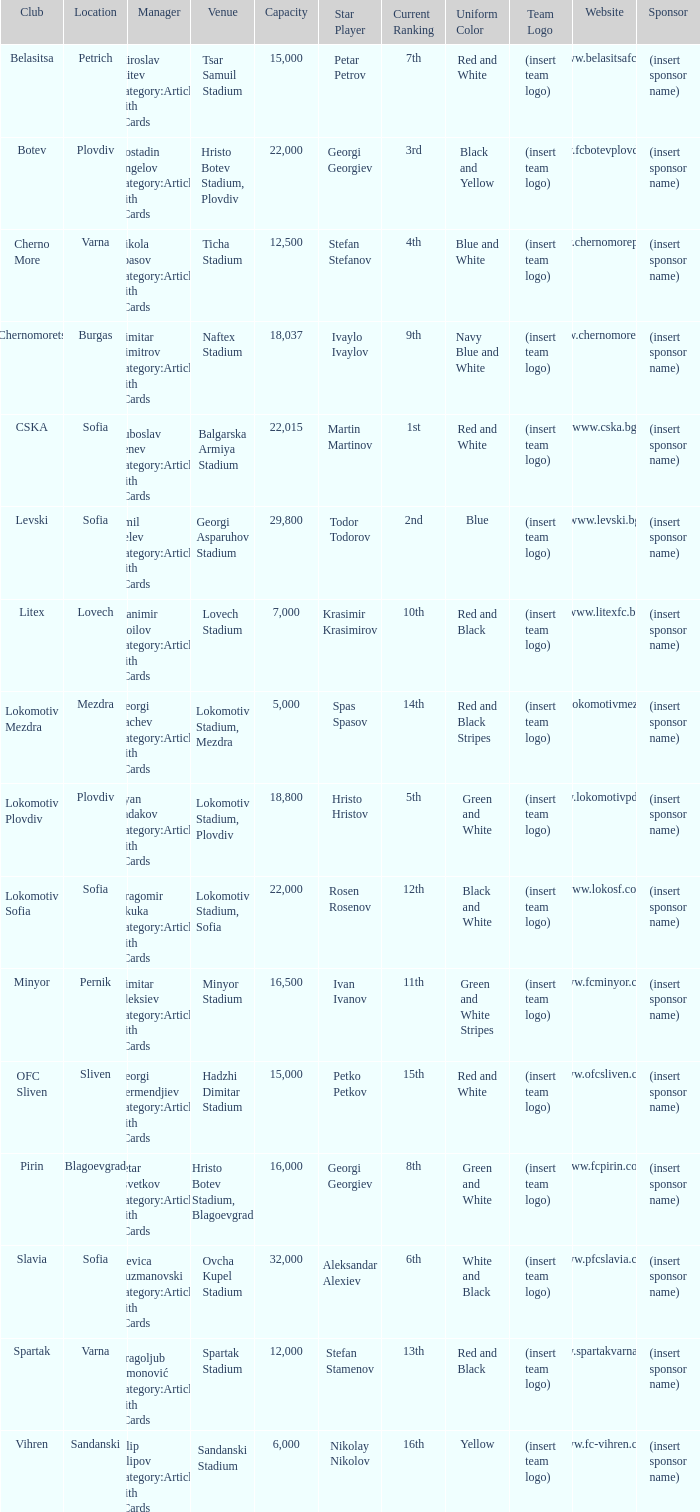What is the highest capacity for the venue, ticha stadium, located in varna? 12500.0. 